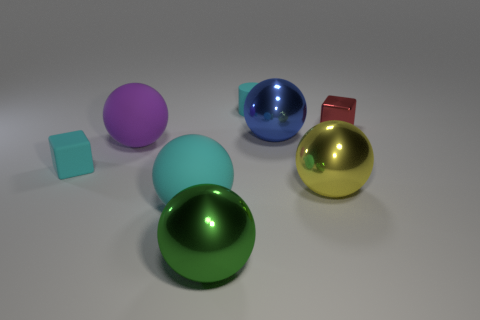Subtract all blue spheres. How many spheres are left? 4 Subtract all yellow balls. How many balls are left? 4 Subtract all red spheres. Subtract all purple cylinders. How many spheres are left? 5 Add 1 small red shiny things. How many objects exist? 9 Subtract all cylinders. How many objects are left? 7 Subtract 1 green spheres. How many objects are left? 7 Subtract all red cubes. Subtract all green metallic objects. How many objects are left? 6 Add 2 small cyan matte cylinders. How many small cyan matte cylinders are left? 3 Add 3 green metal cylinders. How many green metal cylinders exist? 3 